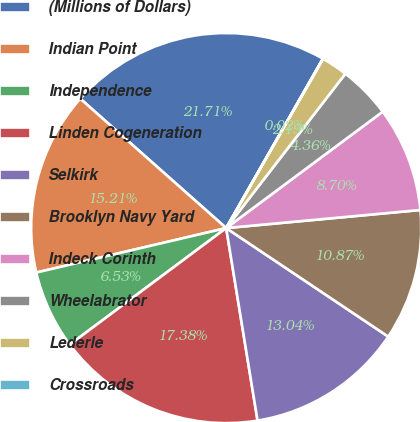<chart> <loc_0><loc_0><loc_500><loc_500><pie_chart><fcel>(Millions of Dollars)<fcel>Indian Point<fcel>Independence<fcel>Linden Cogeneration<fcel>Selkirk<fcel>Brooklyn Navy Yard<fcel>Indeck Corinth<fcel>Wheelabrator<fcel>Lederle<fcel>Crossroads<nl><fcel>21.71%<fcel>15.21%<fcel>6.53%<fcel>17.38%<fcel>13.04%<fcel>10.87%<fcel>8.7%<fcel>4.36%<fcel>2.19%<fcel>0.02%<nl></chart> 